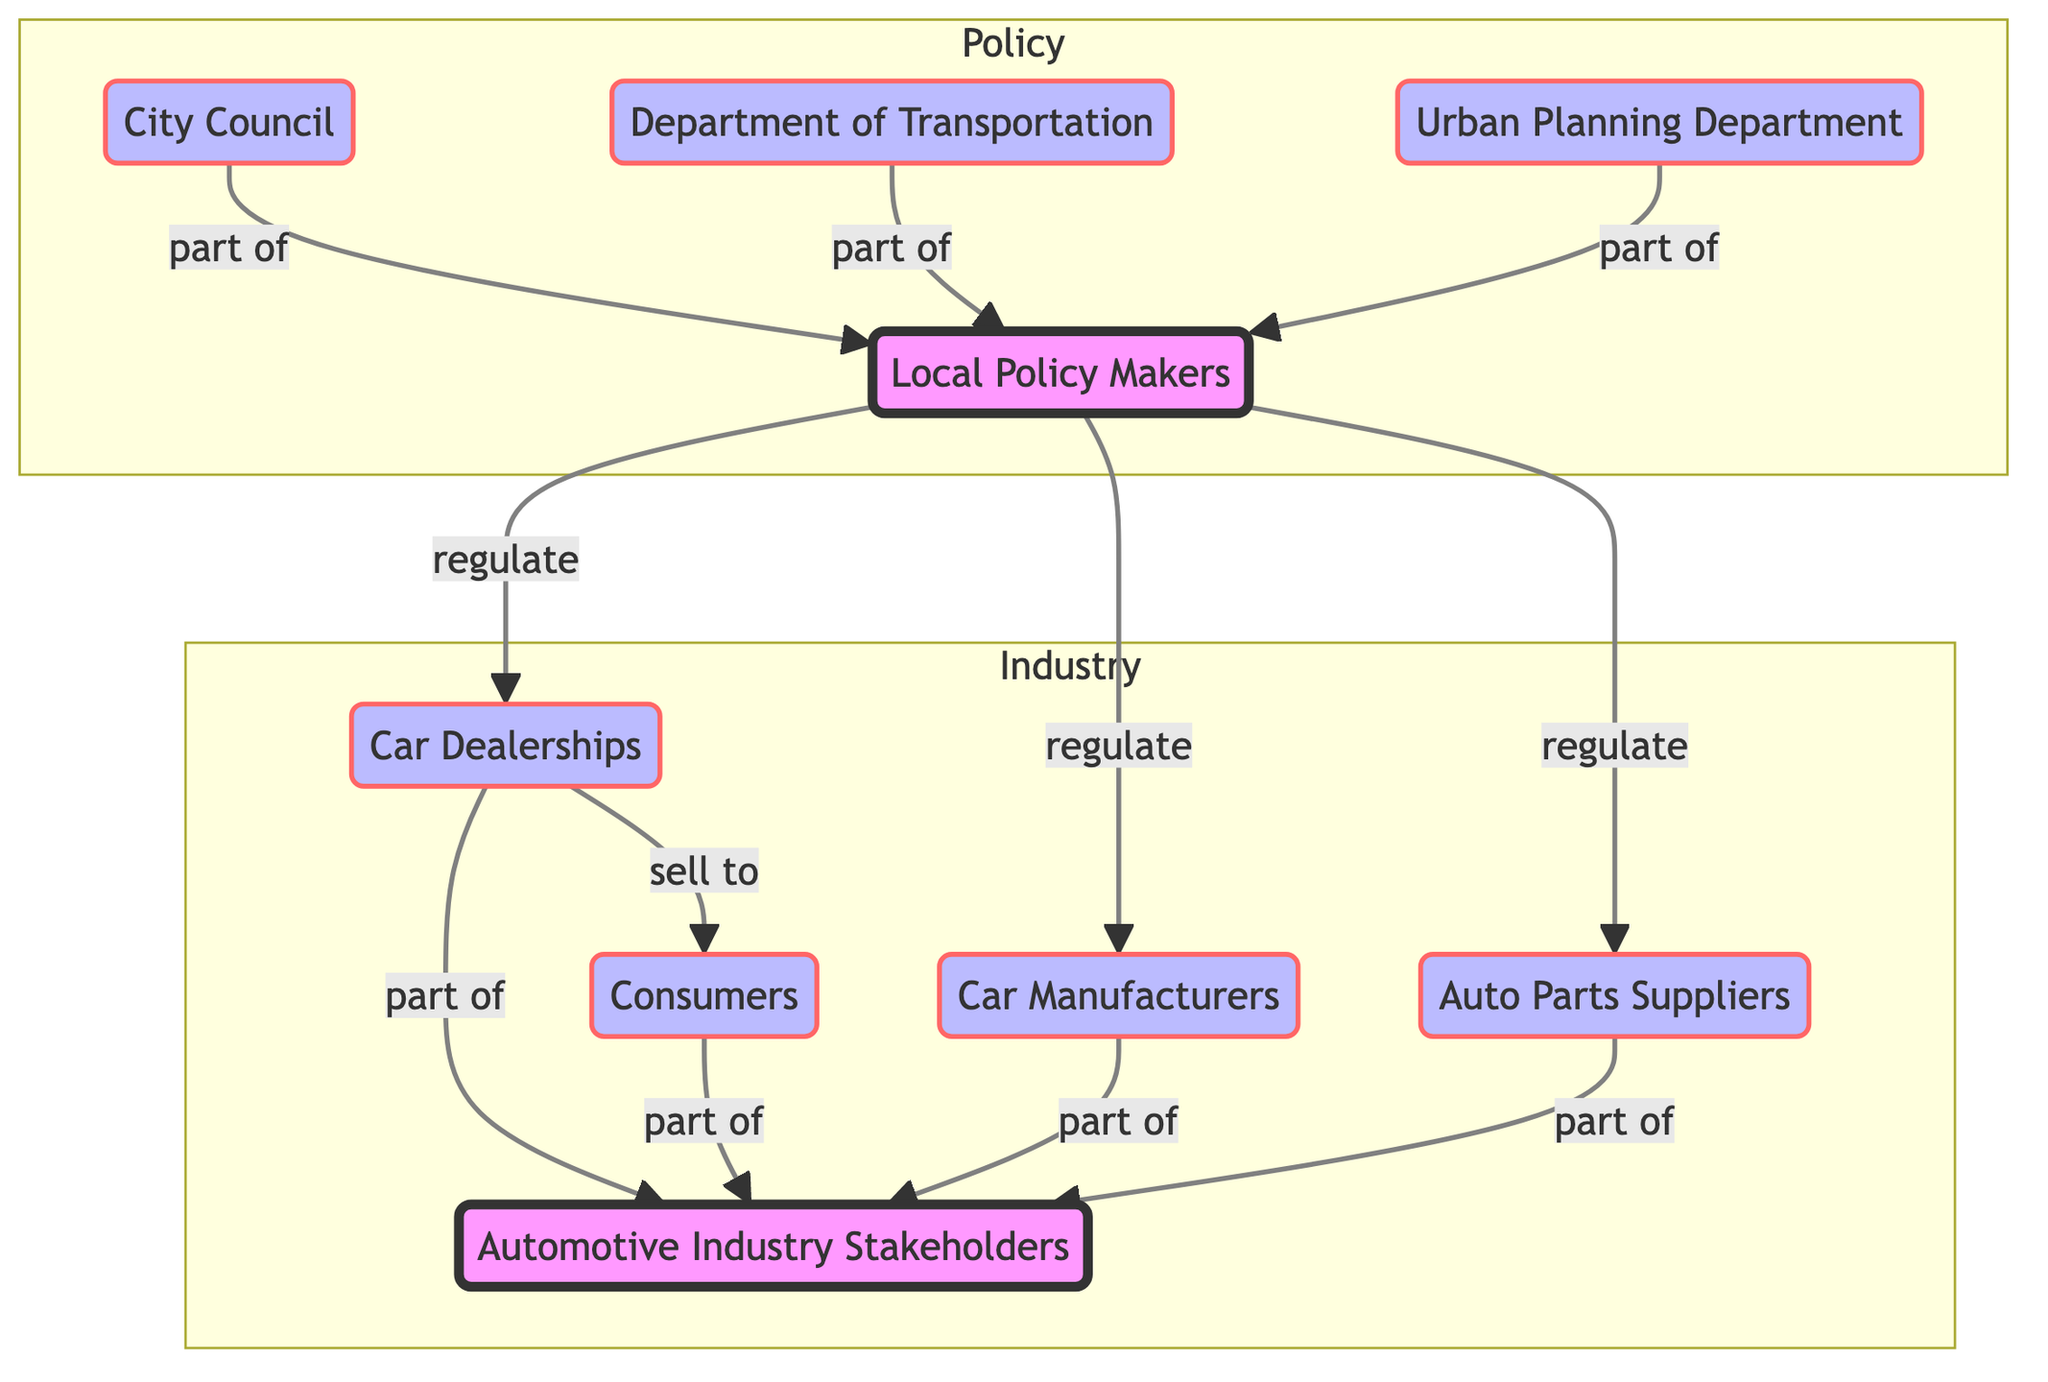What are the groups represented in the diagram? The diagram shows two groups: "Local Policy Makers" and "Automotive Industry Stakeholders." These are highlighted as group nodes in the network.
Answer: Local Policy Makers, Automotive Industry Stakeholders How many entities are part of the Automotive Industry Stakeholders group? There are four entities connected to the Automotive Industry Stakeholders: "Car Dealerships," "Car Manufacturers," "Auto Parts Suppliers," and "Consumers." Counting these gives a total of four.
Answer: 4 Who regulates Car Dealerships? The "PolicyMakers" node has a directed edge labeled "regulate" that leads to "Car Dealerships," indicating that Policy Makers are responsible for regulation.
Answer: Policy Makers What is the relationship between Consumers and Car Dealerships? The arrow from "Car Dealerships" to "Consumers" with the label "sell to" clearly indicates that the Car Dealerships sell vehicles to Consumers.
Answer: sell to Which department is part of the Local Policy Makers? The diagram contains multiple edges from "City Council," "Department of Transportation," and "Urban Planning Department" to "Policy Makers," showing that all these departments are part of the Local Policy Makers.
Answer: City Council, Department of Transportation, Urban Planning Department How many total connections (edges) are shown in the diagram? By counting each connection represented in the edges, there are a total of 10 connections in the network, denoted by the lines and labels in the diagram.
Answer: 10 What type of relationship links Policy Makers to Auto Parts Suppliers? The diagram displays a directed edge labeled "regulate" from "Policy Makers" to "Auto Parts Suppliers," depicting a regulatory relationship.
Answer: regulate Which node has a direct connection to both Policy Makers and the Automotive Industry Stakeholders? "Car Dealerships" is the only node that has edges leading to both the "Policy Makers" (for regulation) and "Automotive Industry Stakeholders" (as part of the industry).
Answer: Car Dealerships How many total nodes are in the diagram? The total number of nodes can be calculated by adding the number of entities and groups listed in the nodes, resulting in a total of 9 nodes in the diagram.
Answer: 9 